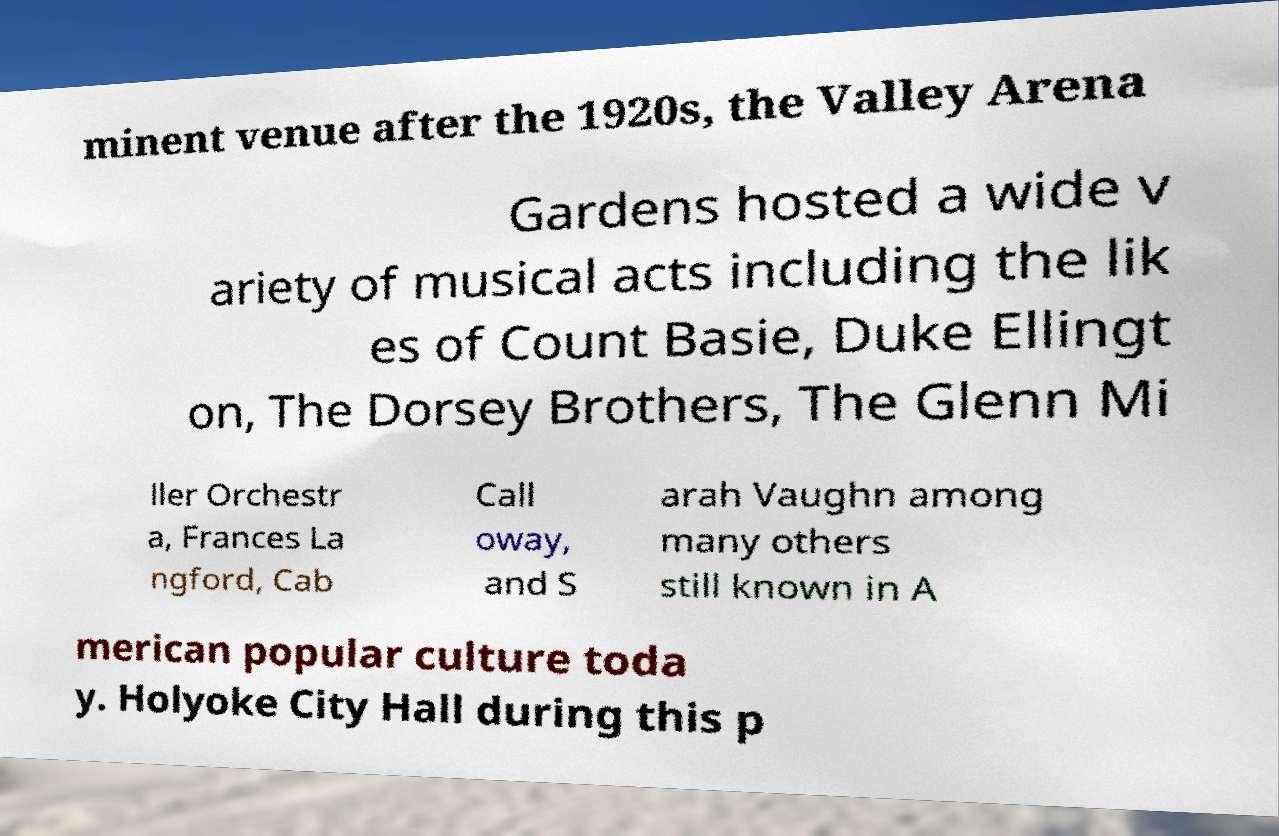Please identify and transcribe the text found in this image. minent venue after the 1920s, the Valley Arena Gardens hosted a wide v ariety of musical acts including the lik es of Count Basie, Duke Ellingt on, The Dorsey Brothers, The Glenn Mi ller Orchestr a, Frances La ngford, Cab Call oway, and S arah Vaughn among many others still known in A merican popular culture toda y. Holyoke City Hall during this p 